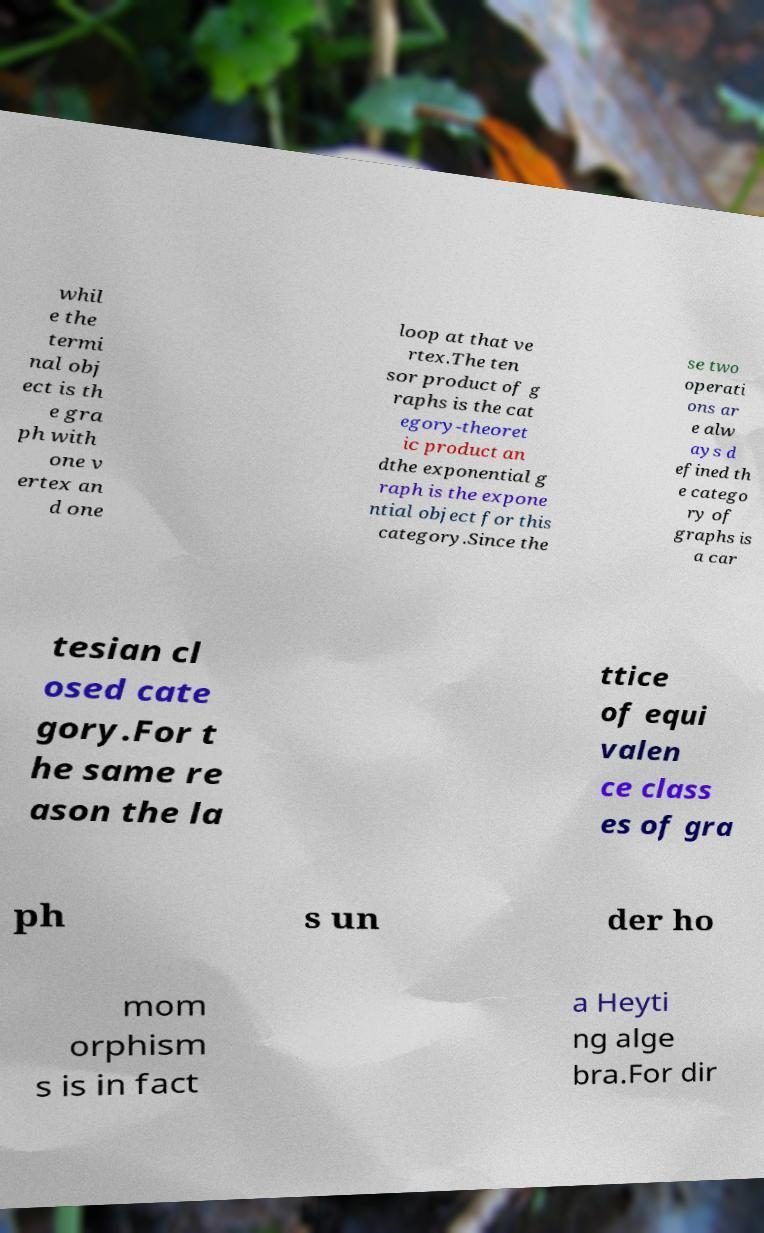Can you read and provide the text displayed in the image?This photo seems to have some interesting text. Can you extract and type it out for me? whil e the termi nal obj ect is th e gra ph with one v ertex an d one loop at that ve rtex.The ten sor product of g raphs is the cat egory-theoret ic product an dthe exponential g raph is the expone ntial object for this category.Since the se two operati ons ar e alw ays d efined th e catego ry of graphs is a car tesian cl osed cate gory.For t he same re ason the la ttice of equi valen ce class es of gra ph s un der ho mom orphism s is in fact a Heyti ng alge bra.For dir 